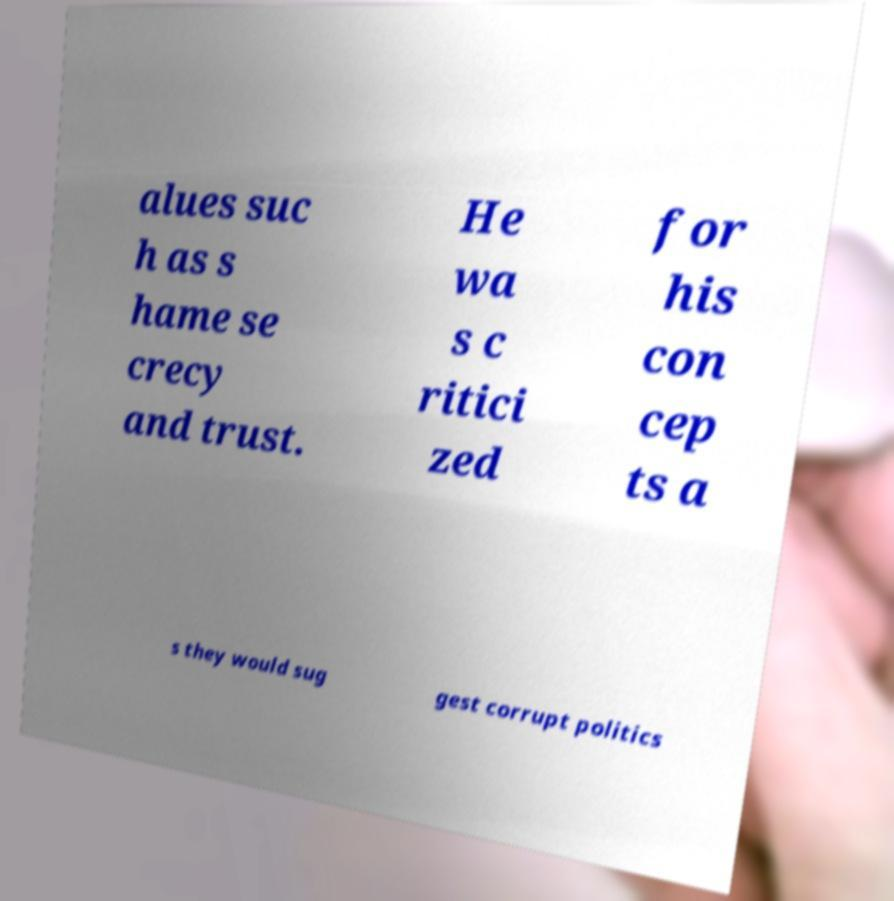I need the written content from this picture converted into text. Can you do that? alues suc h as s hame se crecy and trust. He wa s c ritici zed for his con cep ts a s they would sug gest corrupt politics 